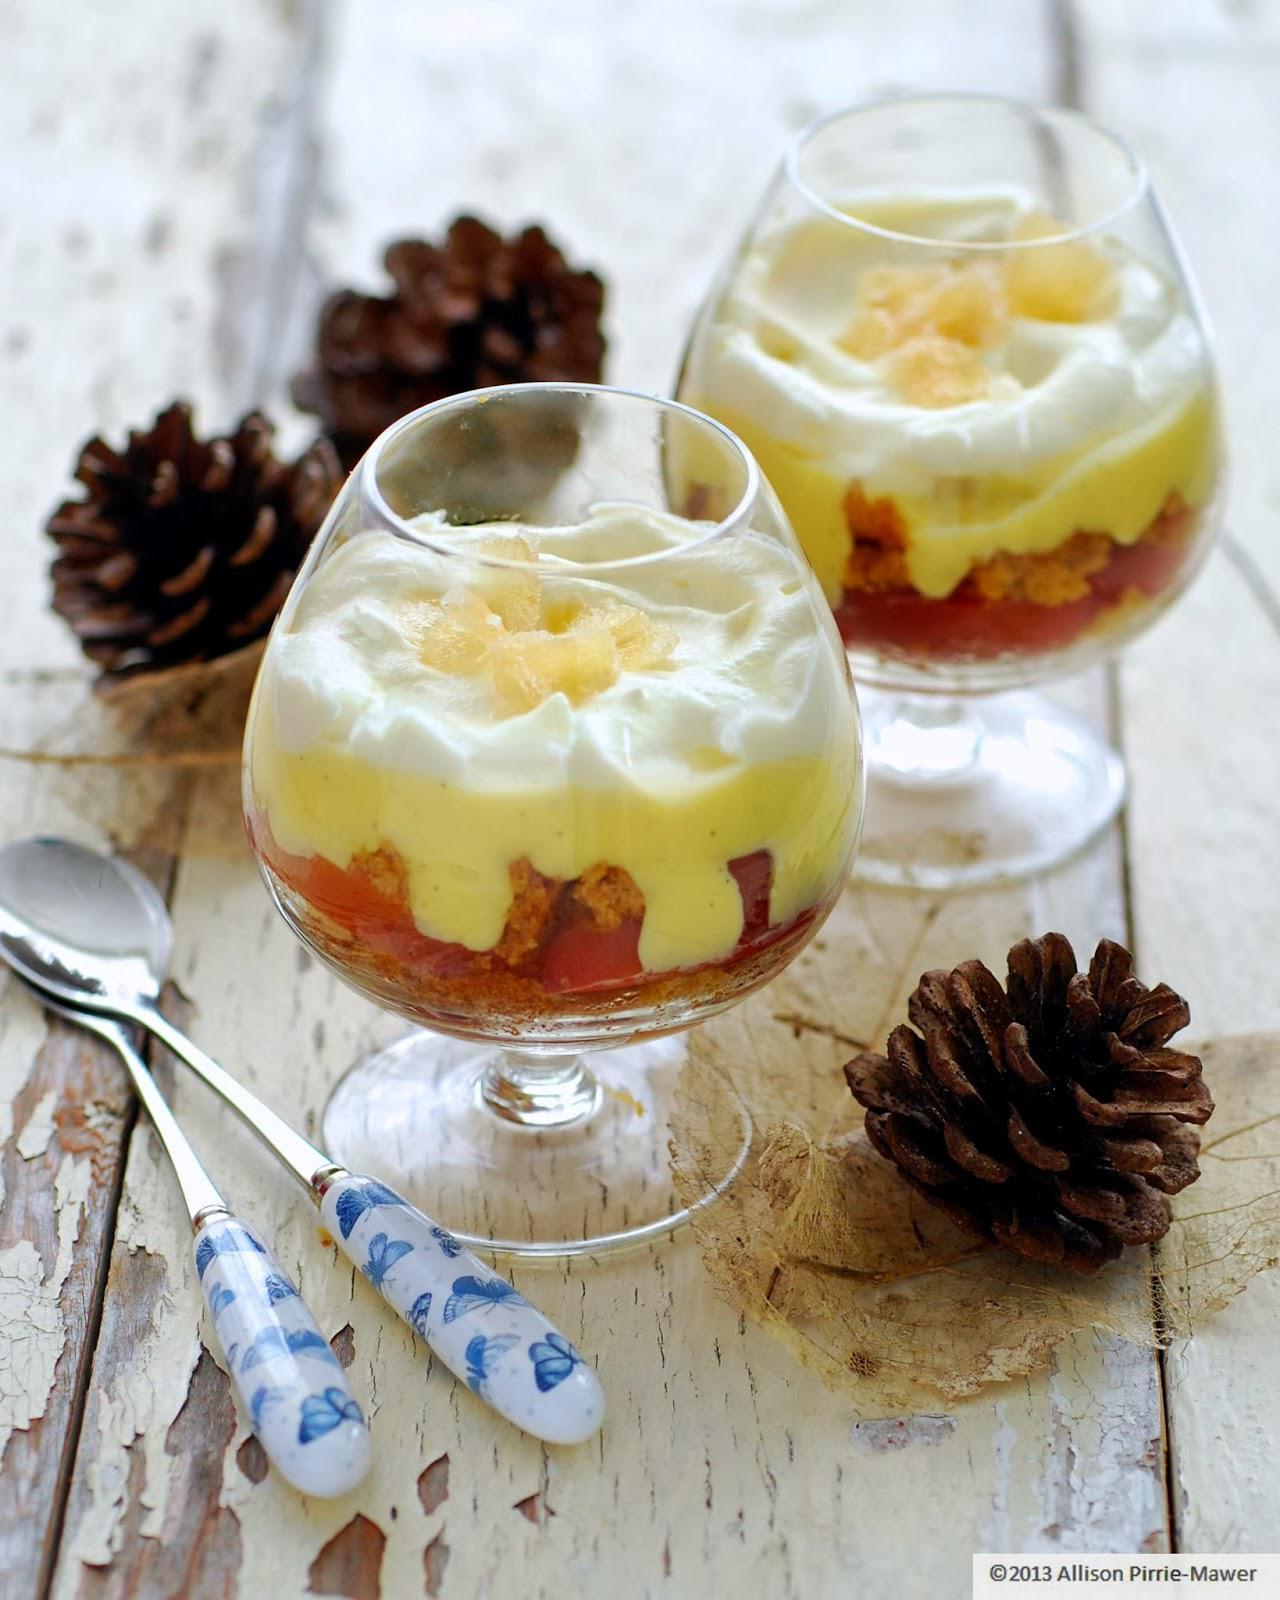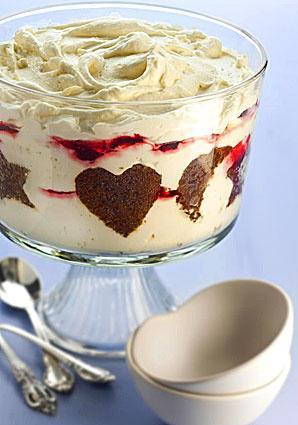The first image is the image on the left, the second image is the image on the right. Evaluate the accuracy of this statement regarding the images: "An image shows a creamy layered dessert with one row of brown shapes arranged inside the glass of the footed serving bowl.". Is it true? Answer yes or no. Yes. 